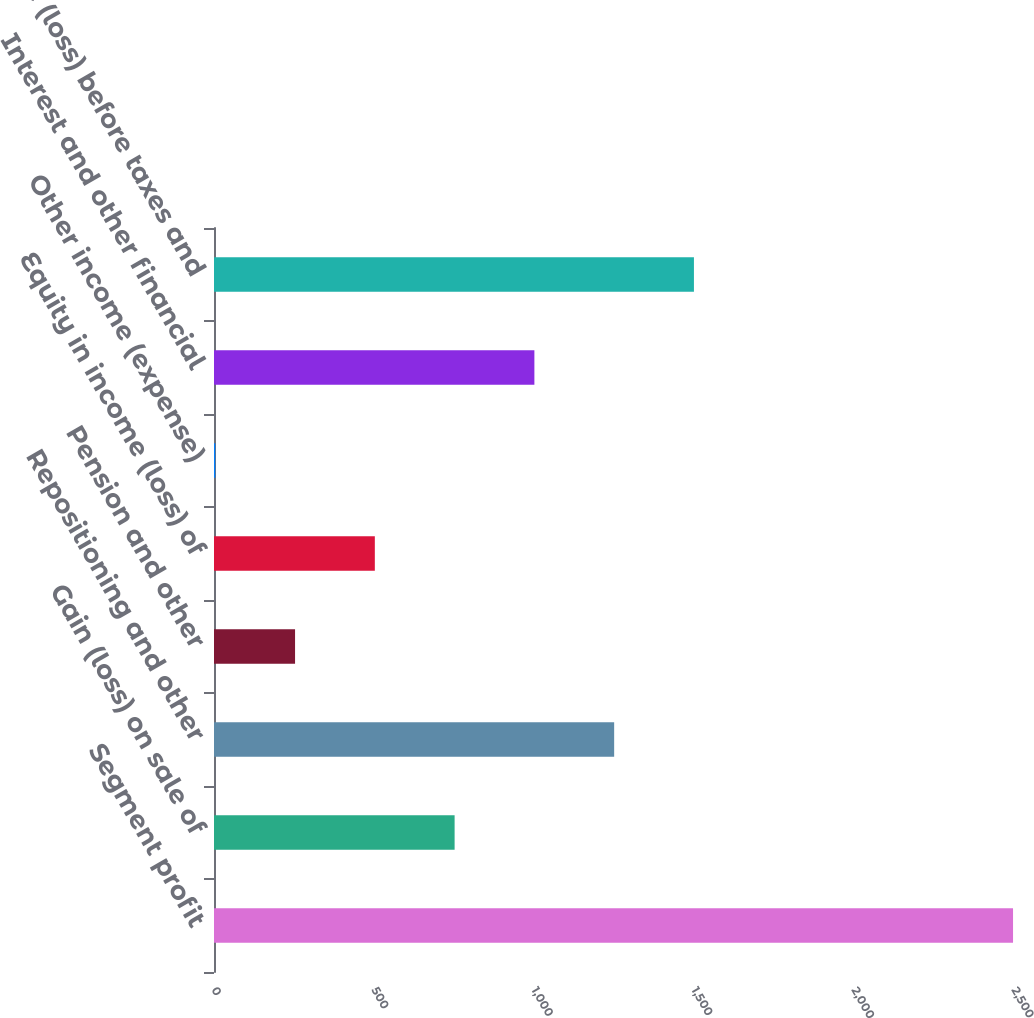Convert chart. <chart><loc_0><loc_0><loc_500><loc_500><bar_chart><fcel>Segment profit<fcel>Gain (loss) on sale of<fcel>Repositioning and other<fcel>Pension and other<fcel>Equity in income (loss) of<fcel>Other income (expense)<fcel>Interest and other financial<fcel>Income (loss) before taxes and<nl><fcel>2497<fcel>751.9<fcel>1250.5<fcel>253.3<fcel>502.6<fcel>4<fcel>1001.2<fcel>1499.8<nl></chart> 